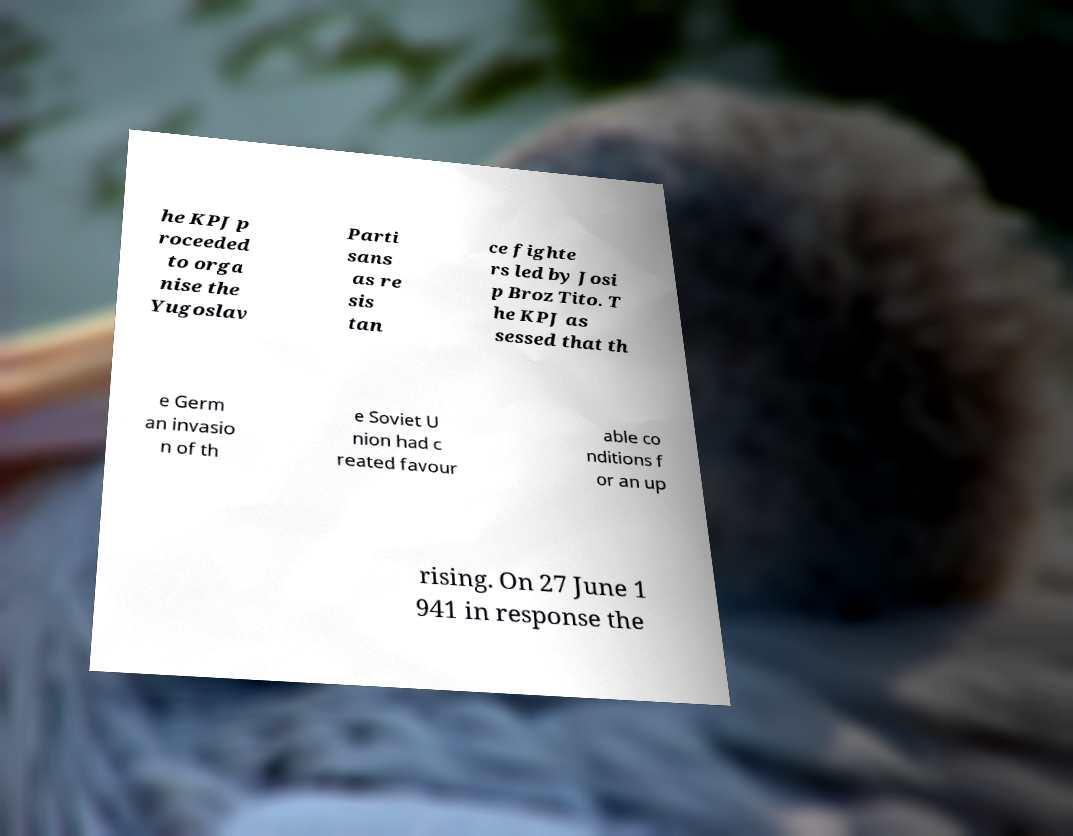What messages or text are displayed in this image? I need them in a readable, typed format. he KPJ p roceeded to orga nise the Yugoslav Parti sans as re sis tan ce fighte rs led by Josi p Broz Tito. T he KPJ as sessed that th e Germ an invasio n of th e Soviet U nion had c reated favour able co nditions f or an up rising. On 27 June 1 941 in response the 